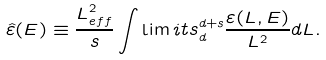Convert formula to latex. <formula><loc_0><loc_0><loc_500><loc_500>\hat { \varepsilon } ( E ) \equiv \frac { L _ { e f f } ^ { 2 } } { s } \int \lim i t s _ { d } ^ { d + s } \frac { \varepsilon ( L , E ) } { L ^ { 2 } } d L .</formula> 